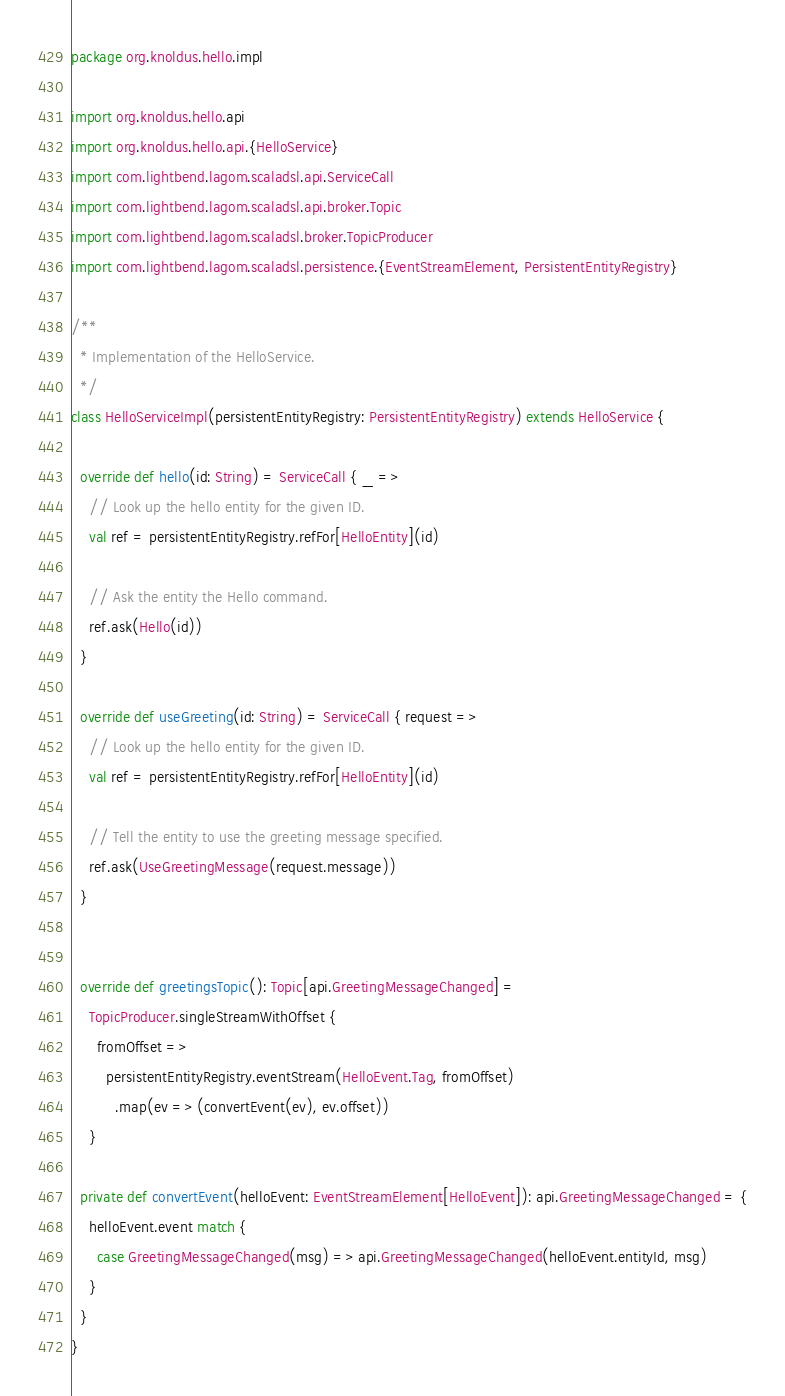Convert code to text. <code><loc_0><loc_0><loc_500><loc_500><_Scala_>package org.knoldus.hello.impl

import org.knoldus.hello.api
import org.knoldus.hello.api.{HelloService}
import com.lightbend.lagom.scaladsl.api.ServiceCall
import com.lightbend.lagom.scaladsl.api.broker.Topic
import com.lightbend.lagom.scaladsl.broker.TopicProducer
import com.lightbend.lagom.scaladsl.persistence.{EventStreamElement, PersistentEntityRegistry}

/**
  * Implementation of the HelloService.
  */
class HelloServiceImpl(persistentEntityRegistry: PersistentEntityRegistry) extends HelloService {

  override def hello(id: String) = ServiceCall { _ =>
    // Look up the hello entity for the given ID.
    val ref = persistentEntityRegistry.refFor[HelloEntity](id)

    // Ask the entity the Hello command.
    ref.ask(Hello(id))
  }

  override def useGreeting(id: String) = ServiceCall { request =>
    // Look up the hello entity for the given ID.
    val ref = persistentEntityRegistry.refFor[HelloEntity](id)

    // Tell the entity to use the greeting message specified.
    ref.ask(UseGreetingMessage(request.message))
  }


  override def greetingsTopic(): Topic[api.GreetingMessageChanged] =
    TopicProducer.singleStreamWithOffset {
      fromOffset =>
        persistentEntityRegistry.eventStream(HelloEvent.Tag, fromOffset)
          .map(ev => (convertEvent(ev), ev.offset))
    }

  private def convertEvent(helloEvent: EventStreamElement[HelloEvent]): api.GreetingMessageChanged = {
    helloEvent.event match {
      case GreetingMessageChanged(msg) => api.GreetingMessageChanged(helloEvent.entityId, msg)
    }
  }
}
</code> 